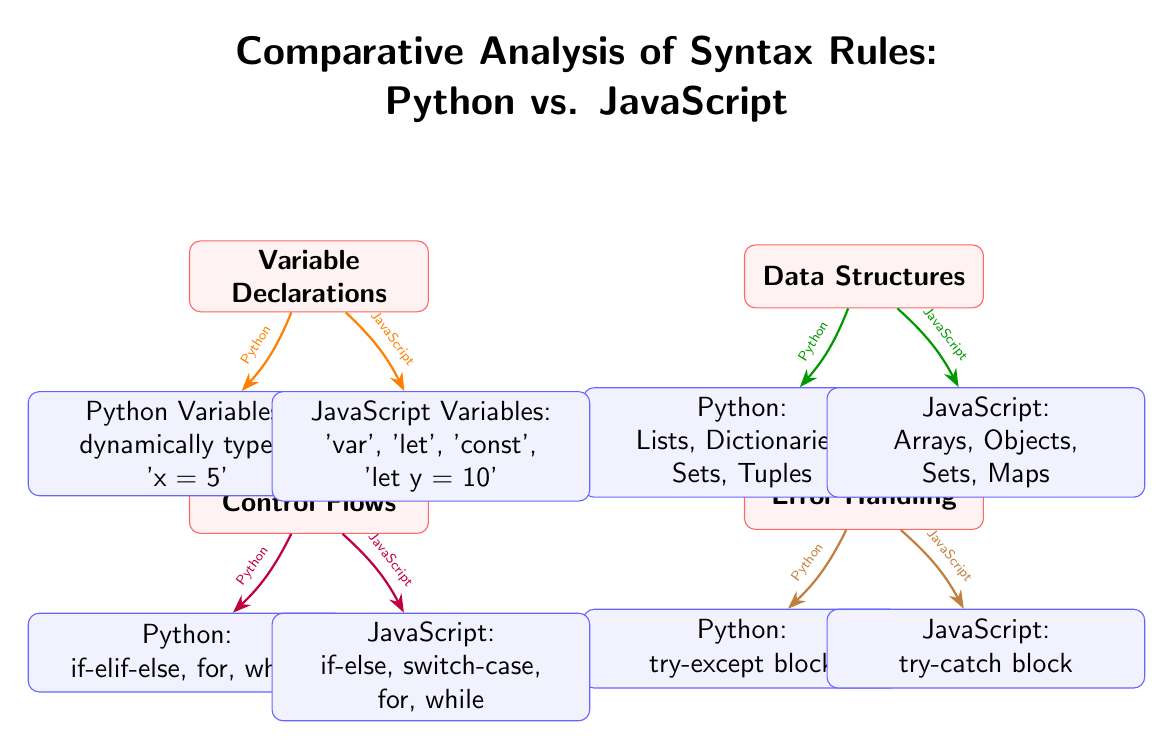What are the types of variable declarations in Python? The diagram indicates that Python uses dynamically typed variables, specifically illustrated by the example 'x = 5'.
Answer: dynamically typed What are the data structures available in JavaScript? According to the diagram, JavaScript has Arrays, Objects, Sets, and Maps as its data structures.
Answer: Arrays, Objects, Sets, Maps Which control flow mechanism is unique to JavaScript? The diagram displays that JavaScript has a switch-case mechanism for control flows, which is not mentioned for Python.
Answer: switch-case How many main topics are compared in this diagram? There are four main topics highlighted in the diagram: Variable Declarations, Data Structures, Control Flows, and Error Handling.
Answer: four What is the primary error handling method in Python? The diagram states that Python uses a try-except block for error handling.
Answer: try-except block What is one of the data structures unique to Python? Looking at the diagram, Python's data structures include Lists, which are unique to it compared to JavaScript.
Answer: Lists How do variable declarations differ fundamentally between Python and JavaScript? The diagram shows that Python uses a single approach (dynamically typed) while JavaScript has multiple methods (var, let, const). This indicates a broader variety in JavaScript's approach.
Answer: multiple methods Which variable declaration keyword is not found in Python? The diagram clearly indicates that the keywords 'var', 'let', and 'const' are specific to JavaScript, signifying that Python does not utilize these keywords.
Answer: var, let, const What type of flow control does Python utilize in addition to if-else statements? The diagram lists for and while as additional control flow constructs that Python uses alongside the if-elif-else structure.
Answer: for, while 